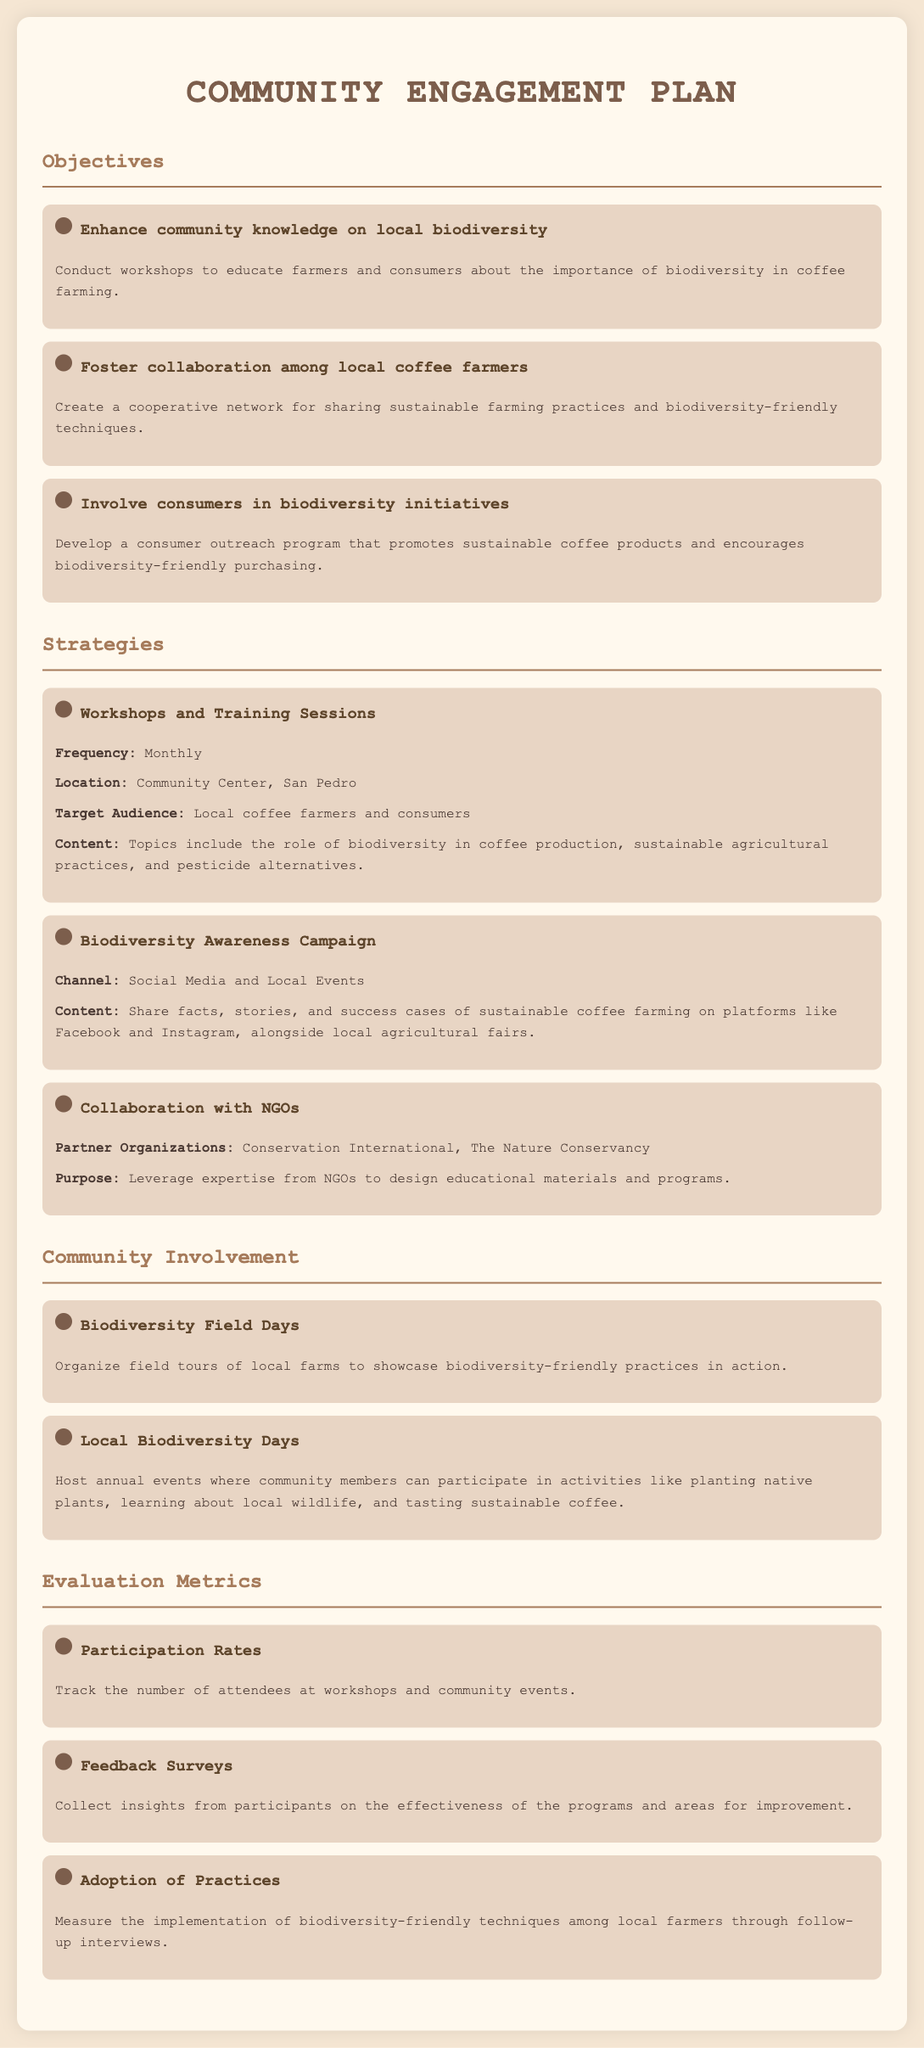What is one objective of the community engagement plan? The document lists three objectives related to biodiversity education, including enhancing community knowledge, fostering collaboration, and involving consumers.
Answer: Enhance community knowledge on local biodiversity How often are workshops held? The strategy section specifies the frequency of workshops for educating farmers and consumers.
Answer: Monthly Where are the training sessions held? The document identifies the location for workshops aimed at the target audience.
Answer: Community Center, San Pedro Which organizations are partners for collaboration? The strategies indicate specific NGOs partnering to help design materials and programs.
Answer: Conservation International, The Nature Conservancy What is one type of community involvement event? The section on community involvement lists events to engage the community, and one type is highlighted.
Answer: Biodiversity Field Days How is participant feedback collected? The metrics for evaluation describe how insights from participants are gathered post-events.
Answer: Feedback Surveys What is a key purpose of the biodiversity awareness campaign? The strategies detail the promotional focus of the awareness campaign targeting audience engagement.
Answer: Share facts, stories, and success cases What will be measured to assess the adoption of practices? The metrics section elucidates the method for assessing implementation through follow-ups.
Answer: Implementation of biodiversity-friendly techniques 